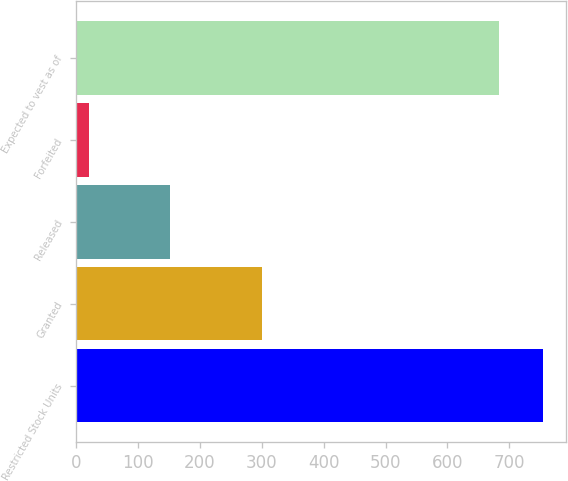<chart> <loc_0><loc_0><loc_500><loc_500><bar_chart><fcel>Restricted Stock Units<fcel>Granted<fcel>Released<fcel>Forfeited<fcel>Expected to vest as of<nl><fcel>754.2<fcel>301<fcel>152<fcel>21<fcel>683<nl></chart> 